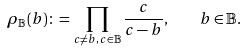<formula> <loc_0><loc_0><loc_500><loc_500>\rho _ { \mathbb { B } } ( b ) \colon = \prod _ { c \neq b , \, c \in \mathbb { B } } \frac { c } { c - b } , \quad b \in \mathbb { B } .</formula> 